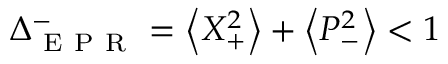Convert formula to latex. <formula><loc_0><loc_0><loc_500><loc_500>\Delta _ { E P R } ^ { - } = \left \langle X _ { + } ^ { 2 } \right \rangle + \left \langle P _ { - } ^ { 2 } \right \rangle < 1</formula> 